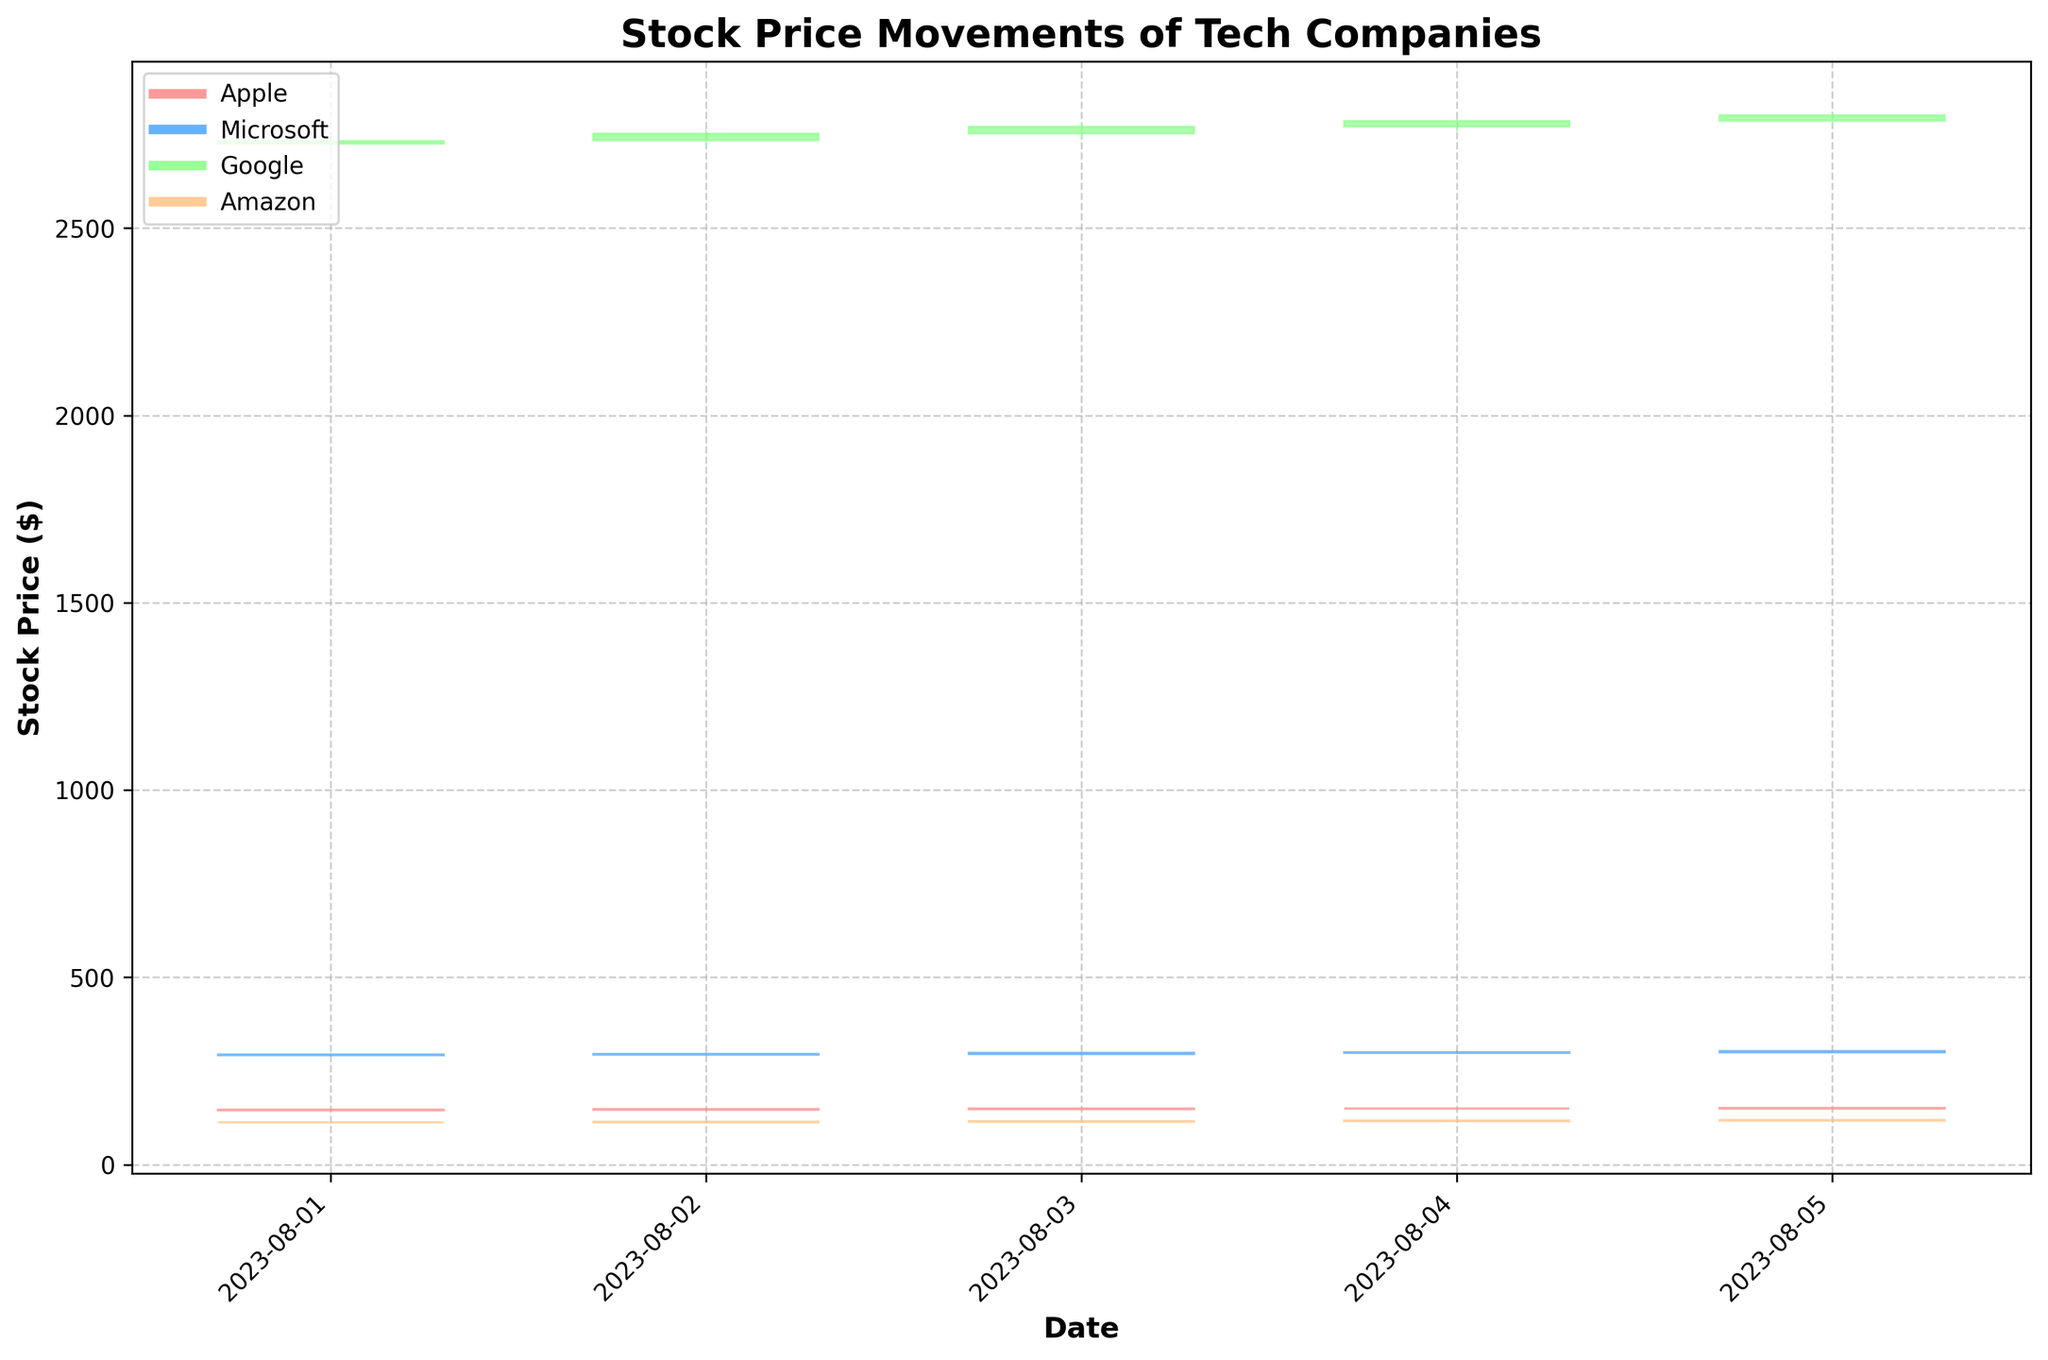what is the title of the candlestick plot? The title of the candlestick plot is located at the top of the figure. By referring to the visual appearance, the title explicitly states what the plot is illustrating.
Answer: Stock Price Movements of Tech Companies Which company had the highest closing price on August 5, 2023? To determine the company with the highest closing price on August 5, 2023, look at the closing prices for each company on that specific date. Google had the highest closing price.
Answer: Google How many days of stock price movements are shown in the figure for each company? By counting the number of data points (candlesticks) associated with each company, we can see that there are five days of stock price movements for each company.
Answer: 5 Which company shows the most significant upward trend during the period? To find the company with the most significant upward trend, look at the overall change from the opening price on the first day to the closing price on the last day. Google shows a consistent increase across all days.
Answer: Google What is the range of the stock prices for Microsoft on August 3, 2023? The range is calculated by finding the difference between the highest and lowest prices for Microsoft on August 3, 2023. The high was $299.99, and the low was $293.45, so the range is $299.99 - $293.45.
Answer: $6.54 How does Apple’s price movement on August 4 compare to August 1-3? Comparing the candlestick for Apple on August 4 to those of August 1–3 involves looking at the opening, high, low, and closing prices. On August 4, Apple continued an upward trend with a higher closing price than the previous days.
Answer: Continued upward trend What is the average closing price for Amazon during the period? To find the average closing price, sum the closing prices for Amazon over the five days and divide by the number of days. The sum is $581.46, so \( 581.46 / 5 \).
Answer: $116.29 Are any companies' stock prices highly volatile during this period? Volatility can be assessed by looking at the length of the candlesticks and the range between the high and low prices. Companies with longer candlesticks and larger wicks show higher volatility. Google shows significant volatility.
Answer: Google Which company had the highest volume of trades on any single day? By looking at the volume of trades for each company over the five days, the highest single-day volume can be identified. Apple on August 5 had the highest volume of trades with 8,500,000 shares.
Answer: Apple What is the color used for an upward movement in Microsoft’s stock price? Referring to the legend and the color coding of the candlesticks, the color for an upward movement in Microsoft's stock price can be identified.
Answer: Light Blue 